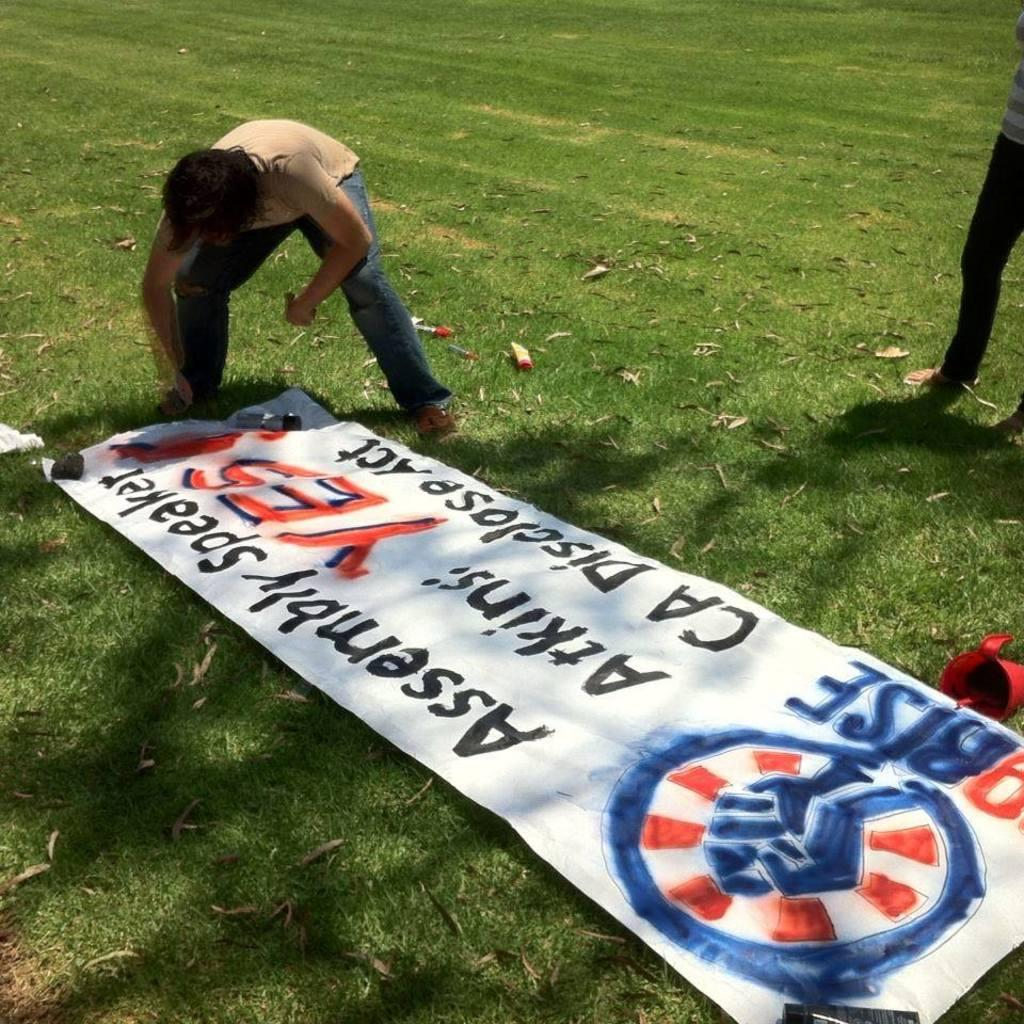What is hanging or displayed in the image? There is a banner in the image. What can be seen on the ground in the image? There are objects on the ground in the image. Are there any other individuals present in the image? Yes, there are other people in the image. What type of tin can be seen being used by the people in the image? There is no tin present in the image, and no indication that people are using any tin objects. 